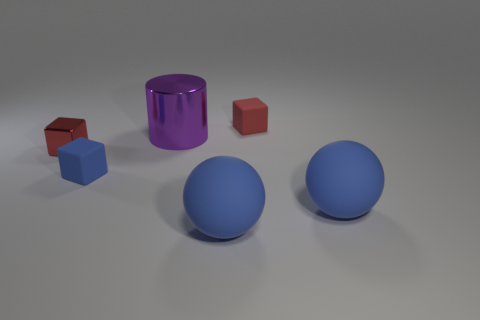Add 4 purple shiny things. How many objects exist? 10 Subtract all cylinders. How many objects are left? 5 Add 5 purple cylinders. How many purple cylinders are left? 6 Add 6 large blue rubber spheres. How many large blue rubber spheres exist? 8 Subtract 0 green cubes. How many objects are left? 6 Subtract all blue rubber objects. Subtract all shiny objects. How many objects are left? 1 